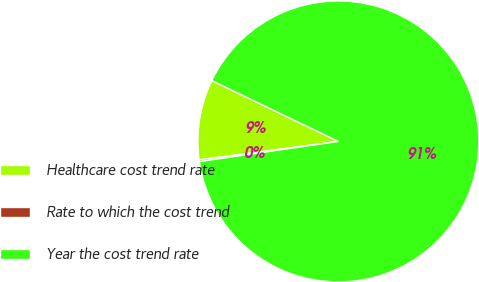Convert chart. <chart><loc_0><loc_0><loc_500><loc_500><pie_chart><fcel>Healthcare cost trend rate<fcel>Rate to which the cost trend<fcel>Year the cost trend rate<nl><fcel>9.23%<fcel>0.2%<fcel>90.57%<nl></chart> 